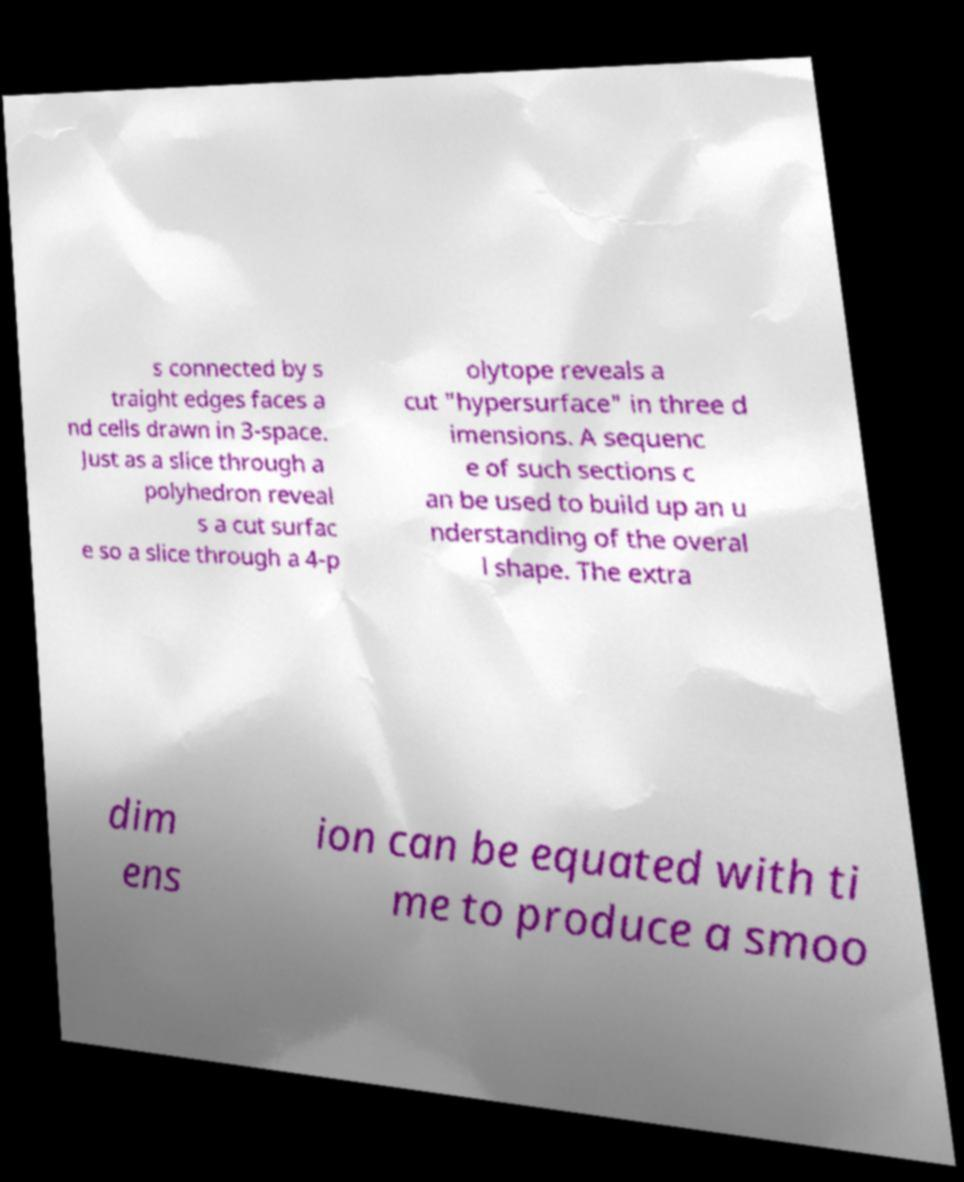Can you read and provide the text displayed in the image?This photo seems to have some interesting text. Can you extract and type it out for me? s connected by s traight edges faces a nd cells drawn in 3-space. Just as a slice through a polyhedron reveal s a cut surfac e so a slice through a 4-p olytope reveals a cut "hypersurface" in three d imensions. A sequenc e of such sections c an be used to build up an u nderstanding of the overal l shape. The extra dim ens ion can be equated with ti me to produce a smoo 